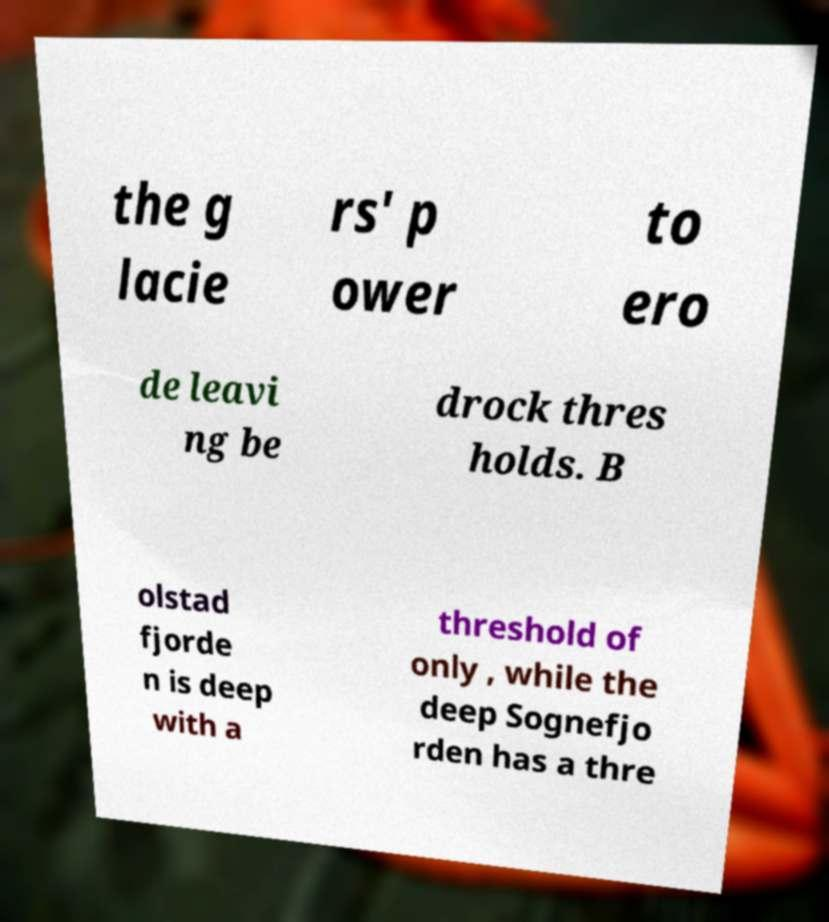Can you accurately transcribe the text from the provided image for me? the g lacie rs' p ower to ero de leavi ng be drock thres holds. B olstad fjorde n is deep with a threshold of only , while the deep Sognefjo rden has a thre 